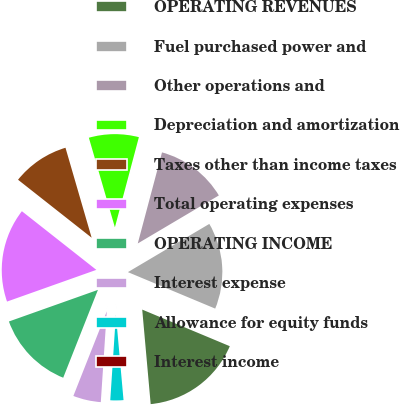<chart> <loc_0><loc_0><loc_500><loc_500><pie_chart><fcel>OPERATING REVENUES<fcel>Fuel purchased power and<fcel>Other operations and<fcel>Depreciation and amortization<fcel>Taxes other than income taxes<fcel>Total operating expenses<fcel>OPERATING INCOME<fcel>Interest expense<fcel>Allowance for equity funds<fcel>Interest income<nl><fcel>17.28%<fcel>14.81%<fcel>12.35%<fcel>8.64%<fcel>9.88%<fcel>16.05%<fcel>13.58%<fcel>4.94%<fcel>2.47%<fcel>0.0%<nl></chart> 